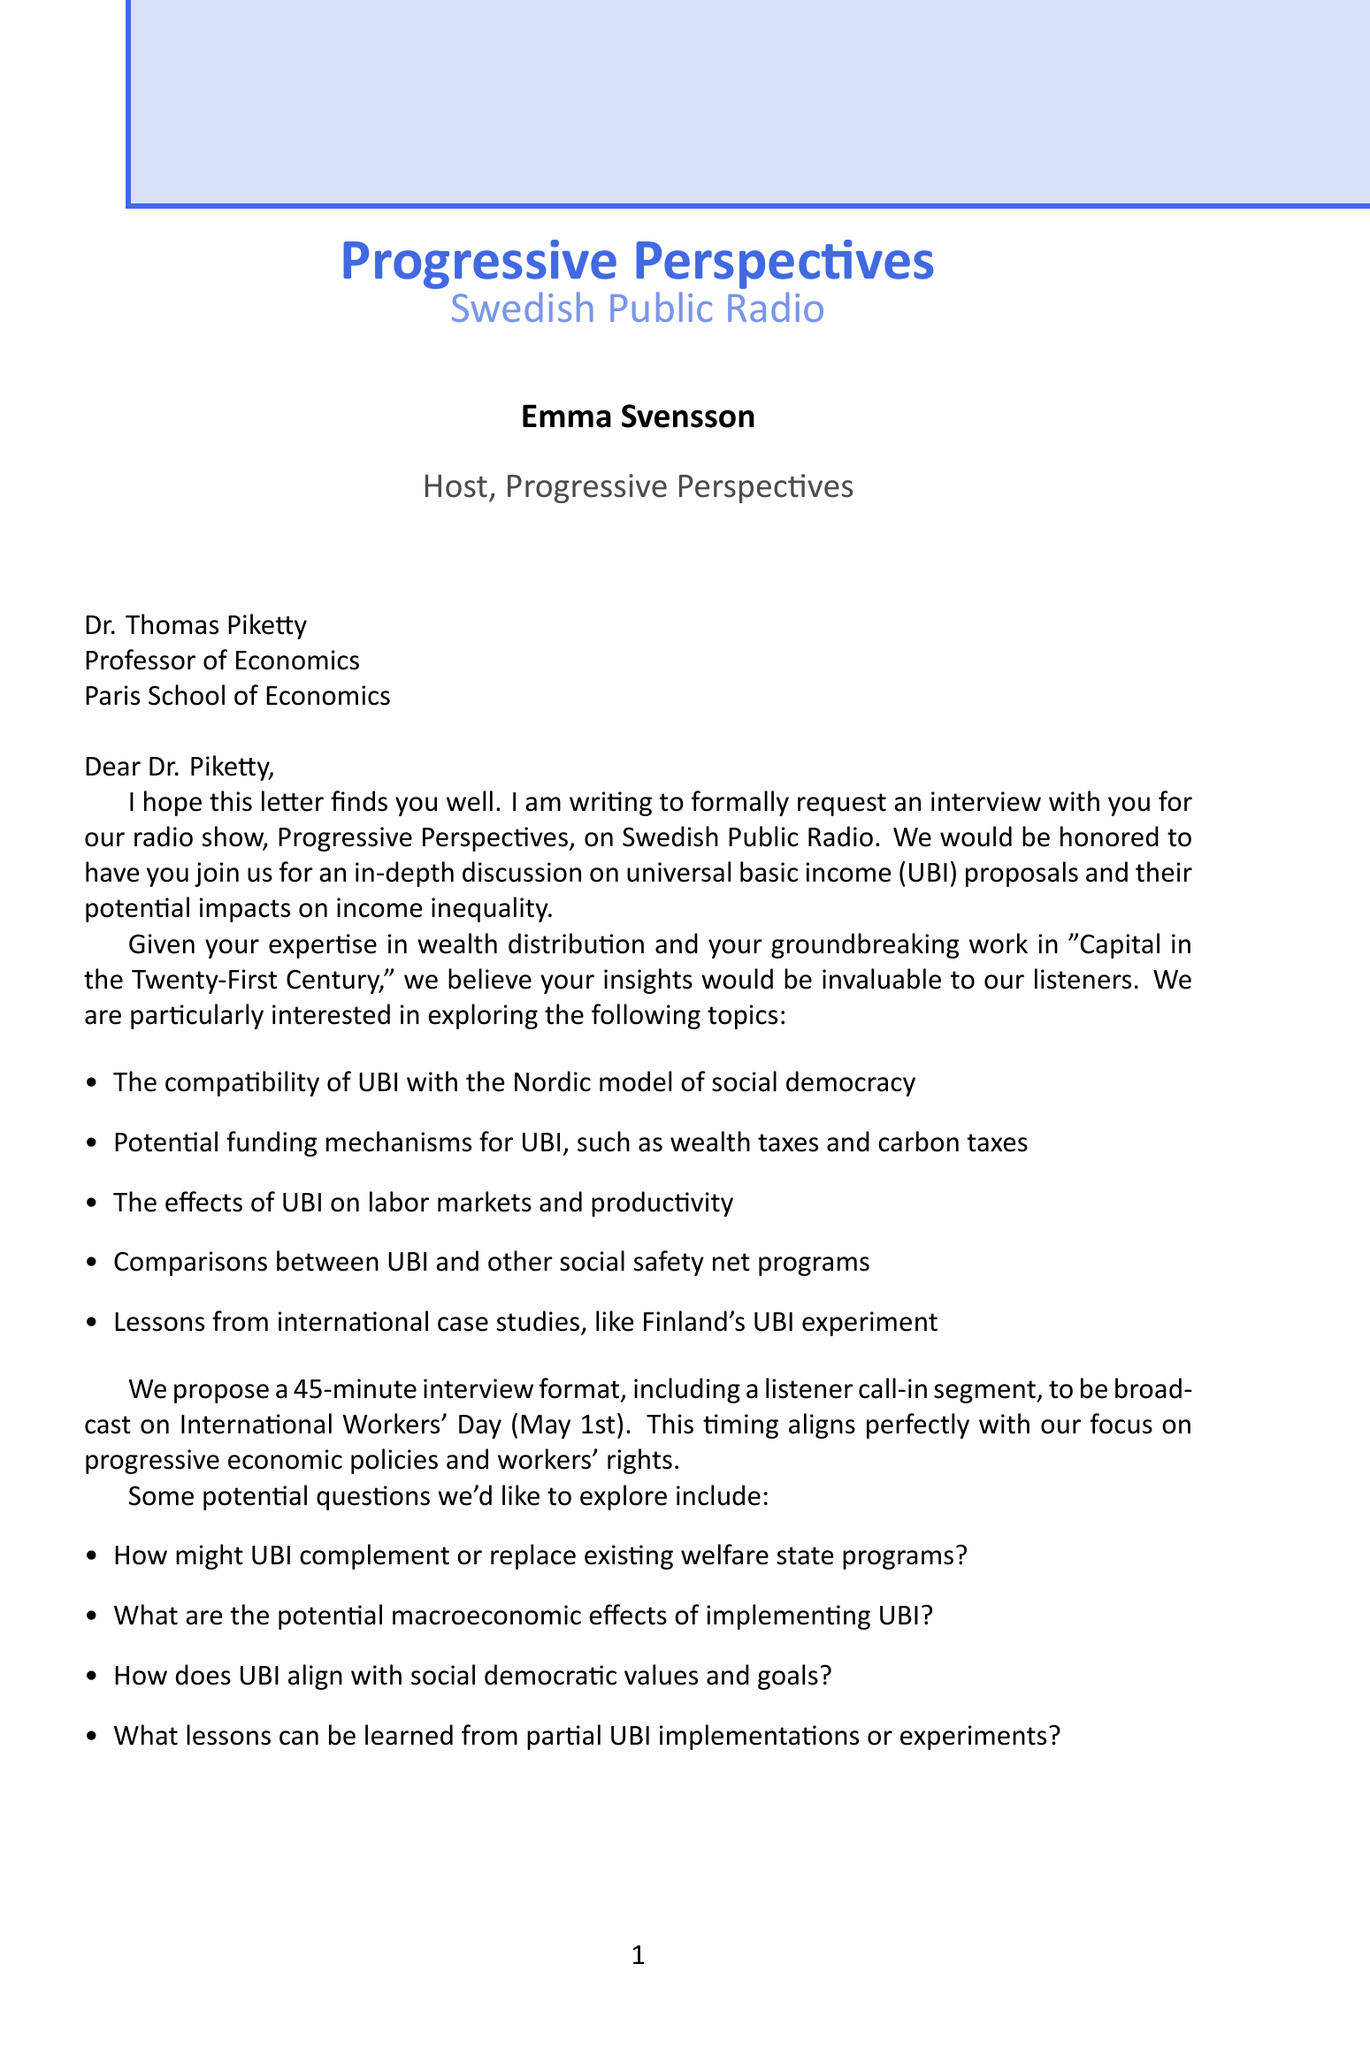What is the name of the radio show? The name of the radio show is explicitly mentioned in the document as "Progressive Perspectives."
Answer: Progressive Perspectives Who is the sender of the letter? The sender is identified in the document, and it states that she is the host of the show.
Answer: Emma Svensson What is the proposed interview duration? The document specifies the duration proposed for the interview segment.
Answer: 45 minutes Which date is the broadcast scheduled for? The letter clearly states the planned date for the broadcast of the interview.
Answer: May 1st What expertise does Dr. Thomas Piketty have? The document mentions Dr. Piketty's specific area of expertise.
Answer: Income inequality, wealth distribution What is one potential funding mechanism for UBI mentioned in the letter? The letter provides examples of funding mechanisms that could support UBI.
Answer: Wealth taxes What topic is emphasized as crucial for public debate in the document? The document points out a key aspect that underscores the importance of the interview.
Answer: Expert insights What is one social democratic angle on UBI discussed in the letter? The document lists perspectives on how UBI relates to social democracy.
Answer: UBI as a tool for reducing poverty What is the main purpose of the requested interview? The document outlines the primary goal for reaching out to Dr. Piketty for an interview.
Answer: Discuss universal basic income proposals What key international case study is mentioned for UBI? The letter refers to an international example relevant to the discussion on UBI.
Answer: Finland's UBI experiment 